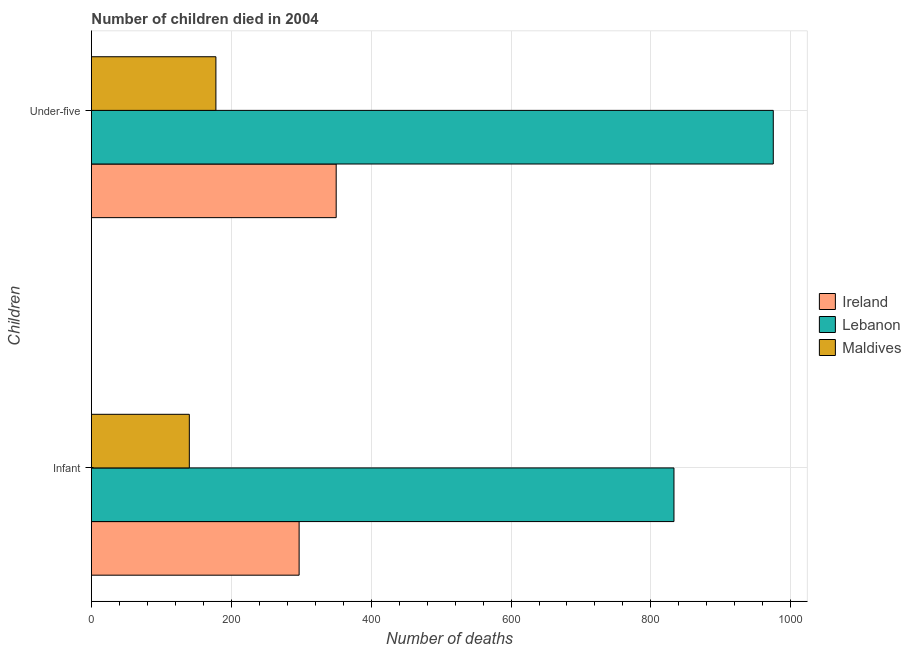How many different coloured bars are there?
Give a very brief answer. 3. How many groups of bars are there?
Your answer should be compact. 2. Are the number of bars per tick equal to the number of legend labels?
Give a very brief answer. Yes. Are the number of bars on each tick of the Y-axis equal?
Keep it short and to the point. Yes. What is the label of the 2nd group of bars from the top?
Your answer should be very brief. Infant. What is the number of infant deaths in Maldives?
Ensure brevity in your answer.  140. Across all countries, what is the maximum number of infant deaths?
Provide a short and direct response. 833. Across all countries, what is the minimum number of under-five deaths?
Offer a terse response. 178. In which country was the number of under-five deaths maximum?
Keep it short and to the point. Lebanon. In which country was the number of under-five deaths minimum?
Make the answer very short. Maldives. What is the total number of under-five deaths in the graph?
Offer a terse response. 1503. What is the difference between the number of under-five deaths in Ireland and that in Maldives?
Make the answer very short. 172. What is the difference between the number of under-five deaths in Maldives and the number of infant deaths in Lebanon?
Provide a succinct answer. -655. What is the average number of under-five deaths per country?
Make the answer very short. 501. What is the difference between the number of under-five deaths and number of infant deaths in Ireland?
Ensure brevity in your answer.  53. In how many countries, is the number of under-five deaths greater than 600 ?
Keep it short and to the point. 1. What is the ratio of the number of infant deaths in Maldives to that in Ireland?
Offer a very short reply. 0.47. What does the 2nd bar from the top in Infant represents?
Provide a short and direct response. Lebanon. What does the 1st bar from the bottom in Under-five represents?
Your answer should be compact. Ireland. How many bars are there?
Your answer should be very brief. 6. How many countries are there in the graph?
Offer a terse response. 3. What is the difference between two consecutive major ticks on the X-axis?
Offer a terse response. 200. Does the graph contain any zero values?
Offer a very short reply. No. Where does the legend appear in the graph?
Offer a terse response. Center right. What is the title of the graph?
Ensure brevity in your answer.  Number of children died in 2004. What is the label or title of the X-axis?
Your response must be concise. Number of deaths. What is the label or title of the Y-axis?
Provide a short and direct response. Children. What is the Number of deaths in Ireland in Infant?
Keep it short and to the point. 297. What is the Number of deaths of Lebanon in Infant?
Offer a very short reply. 833. What is the Number of deaths in Maldives in Infant?
Keep it short and to the point. 140. What is the Number of deaths in Ireland in Under-five?
Ensure brevity in your answer.  350. What is the Number of deaths of Lebanon in Under-five?
Your response must be concise. 975. What is the Number of deaths of Maldives in Under-five?
Make the answer very short. 178. Across all Children, what is the maximum Number of deaths in Ireland?
Ensure brevity in your answer.  350. Across all Children, what is the maximum Number of deaths of Lebanon?
Provide a succinct answer. 975. Across all Children, what is the maximum Number of deaths of Maldives?
Ensure brevity in your answer.  178. Across all Children, what is the minimum Number of deaths in Ireland?
Make the answer very short. 297. Across all Children, what is the minimum Number of deaths of Lebanon?
Your answer should be very brief. 833. Across all Children, what is the minimum Number of deaths in Maldives?
Provide a short and direct response. 140. What is the total Number of deaths of Ireland in the graph?
Provide a short and direct response. 647. What is the total Number of deaths of Lebanon in the graph?
Your answer should be very brief. 1808. What is the total Number of deaths in Maldives in the graph?
Your answer should be very brief. 318. What is the difference between the Number of deaths in Ireland in Infant and that in Under-five?
Provide a short and direct response. -53. What is the difference between the Number of deaths of Lebanon in Infant and that in Under-five?
Your response must be concise. -142. What is the difference between the Number of deaths of Maldives in Infant and that in Under-five?
Provide a succinct answer. -38. What is the difference between the Number of deaths of Ireland in Infant and the Number of deaths of Lebanon in Under-five?
Keep it short and to the point. -678. What is the difference between the Number of deaths in Ireland in Infant and the Number of deaths in Maldives in Under-five?
Ensure brevity in your answer.  119. What is the difference between the Number of deaths in Lebanon in Infant and the Number of deaths in Maldives in Under-five?
Make the answer very short. 655. What is the average Number of deaths of Ireland per Children?
Offer a terse response. 323.5. What is the average Number of deaths of Lebanon per Children?
Offer a very short reply. 904. What is the average Number of deaths of Maldives per Children?
Your answer should be very brief. 159. What is the difference between the Number of deaths in Ireland and Number of deaths in Lebanon in Infant?
Give a very brief answer. -536. What is the difference between the Number of deaths in Ireland and Number of deaths in Maldives in Infant?
Your answer should be compact. 157. What is the difference between the Number of deaths of Lebanon and Number of deaths of Maldives in Infant?
Your answer should be very brief. 693. What is the difference between the Number of deaths of Ireland and Number of deaths of Lebanon in Under-five?
Your response must be concise. -625. What is the difference between the Number of deaths of Ireland and Number of deaths of Maldives in Under-five?
Offer a very short reply. 172. What is the difference between the Number of deaths of Lebanon and Number of deaths of Maldives in Under-five?
Provide a succinct answer. 797. What is the ratio of the Number of deaths in Ireland in Infant to that in Under-five?
Your answer should be very brief. 0.85. What is the ratio of the Number of deaths of Lebanon in Infant to that in Under-five?
Offer a terse response. 0.85. What is the ratio of the Number of deaths in Maldives in Infant to that in Under-five?
Ensure brevity in your answer.  0.79. What is the difference between the highest and the second highest Number of deaths of Lebanon?
Keep it short and to the point. 142. What is the difference between the highest and the lowest Number of deaths in Ireland?
Ensure brevity in your answer.  53. What is the difference between the highest and the lowest Number of deaths of Lebanon?
Ensure brevity in your answer.  142. 